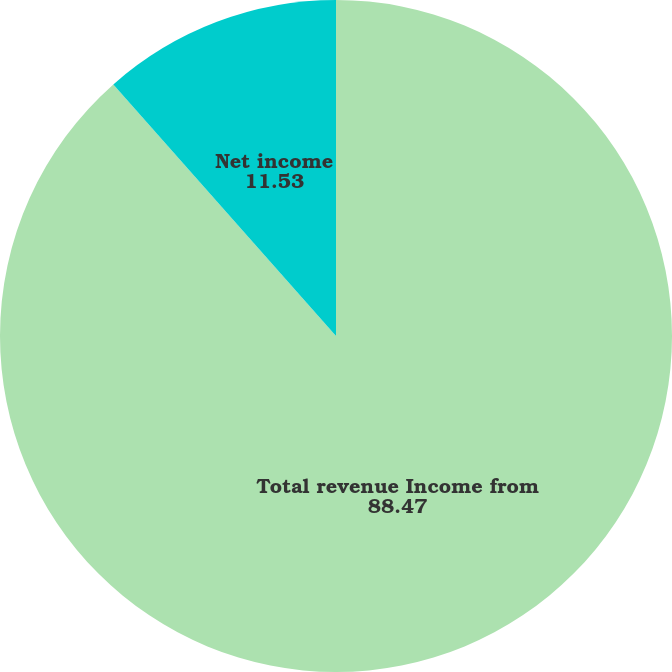Convert chart to OTSL. <chart><loc_0><loc_0><loc_500><loc_500><pie_chart><fcel>Total revenue Income from<fcel>Net income<nl><fcel>88.47%<fcel>11.53%<nl></chart> 